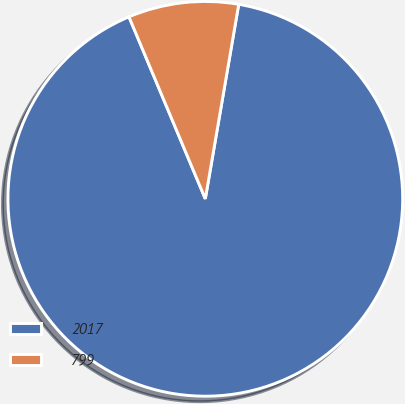Convert chart to OTSL. <chart><loc_0><loc_0><loc_500><loc_500><pie_chart><fcel>2017<fcel>799<nl><fcel>90.97%<fcel>9.03%<nl></chart> 